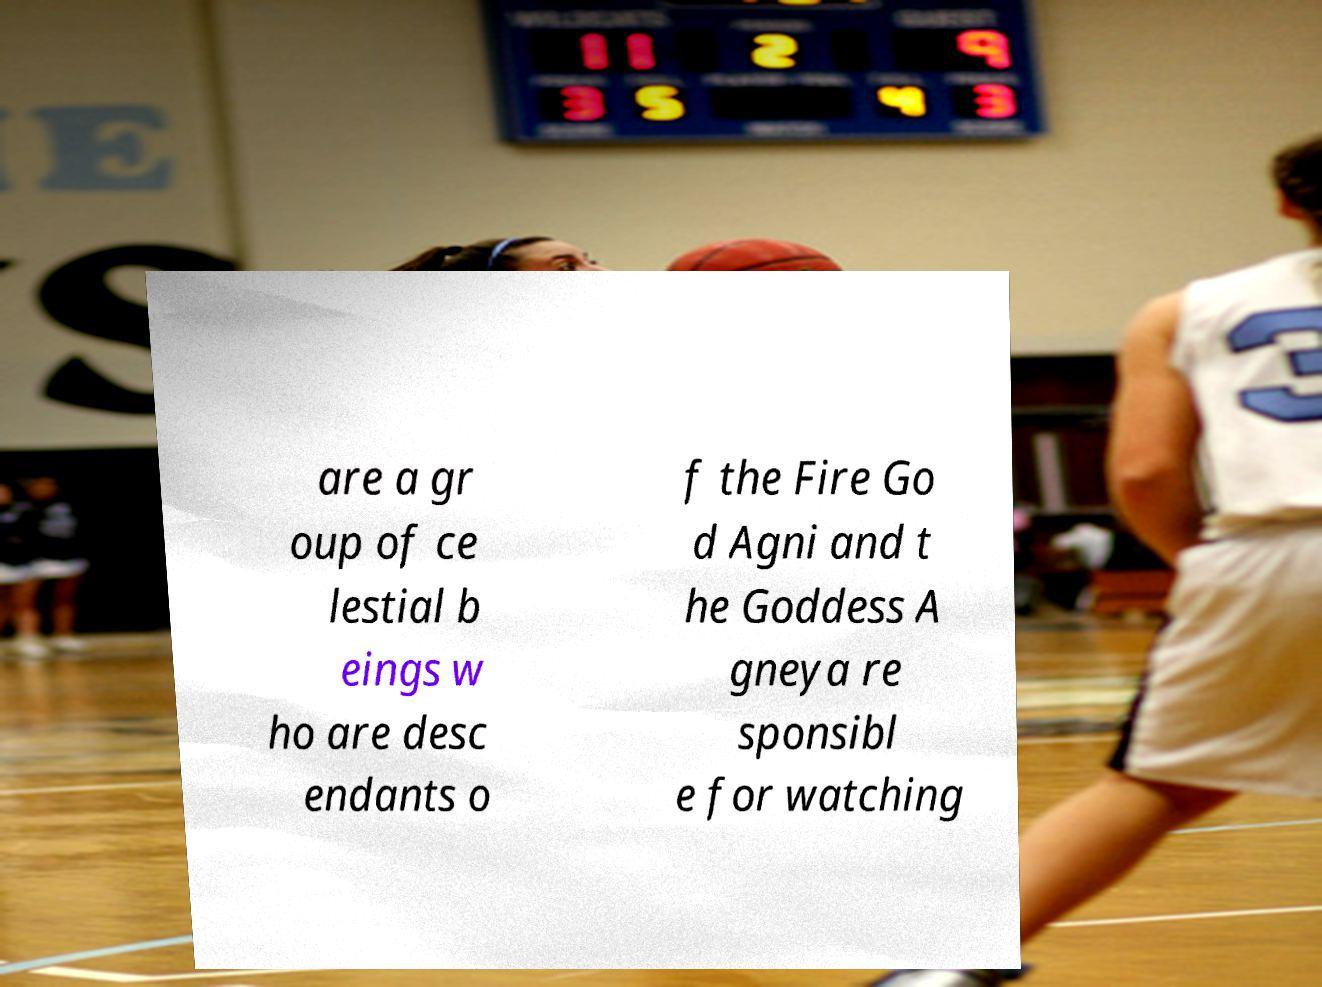What messages or text are displayed in this image? I need them in a readable, typed format. are a gr oup of ce lestial b eings w ho are desc endants o f the Fire Go d Agni and t he Goddess A gneya re sponsibl e for watching 